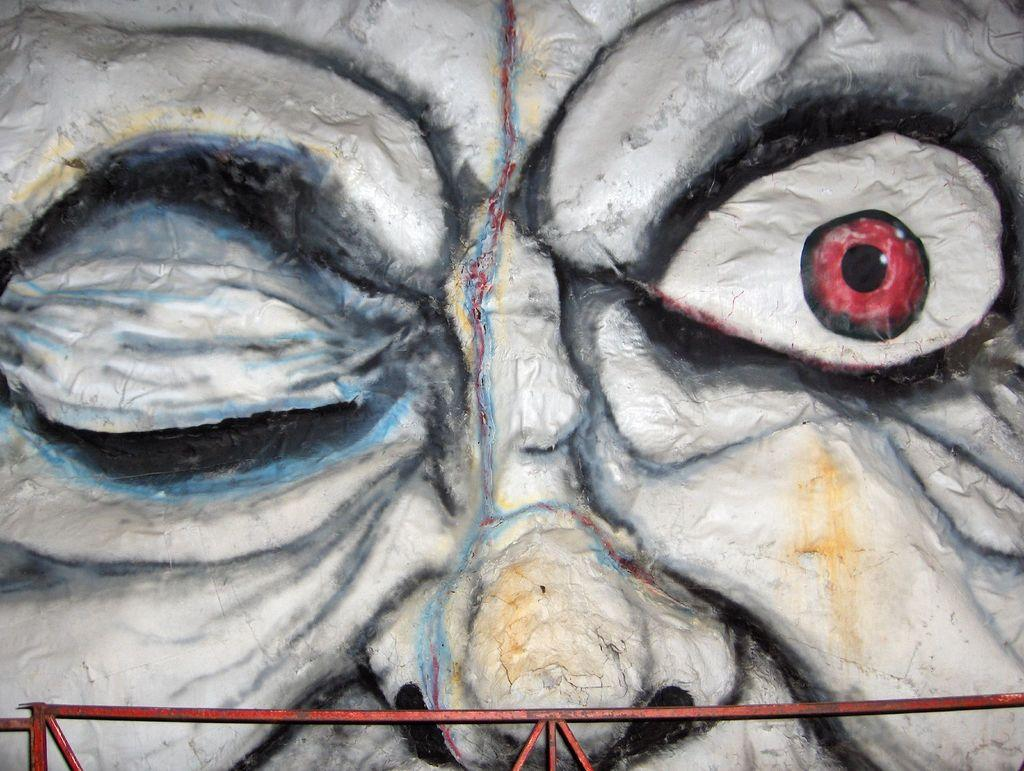What is depicted in the painting in the image? There is a painting of eyes and a nose in the image. What can be seen at the bottom of the image? There are rods at the bottom of the image. What type of acoustics can be heard coming from the painting in the image? There is no indication in the image that the painting is producing any sound or acoustics. Is there a porter present in the image? There is no reference to a porter in the image. What type of coat is the painting wearing in the image? The painting is not a person and therefore does not wear a coat. 